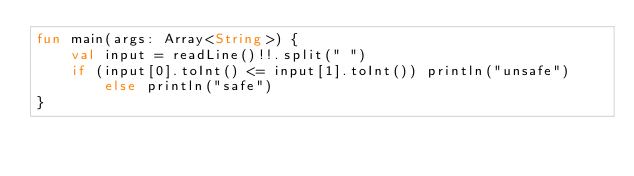<code> <loc_0><loc_0><loc_500><loc_500><_Kotlin_>fun main(args: Array<String>) {
    val input = readLine()!!.split(" ")
    if (input[0].toInt() <= input[1].toInt()) println("unsafe") else println("safe")
}
</code> 